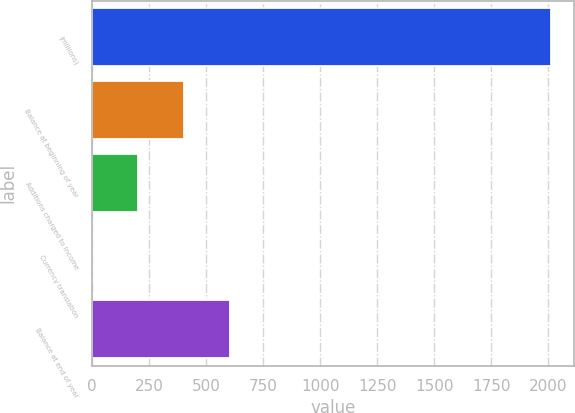Convert chart. <chart><loc_0><loc_0><loc_500><loc_500><bar_chart><fcel>(millions)<fcel>Balance at beginning of year<fcel>Additions charged to income<fcel>Currency translation<fcel>Balance at end of year<nl><fcel>2012<fcel>403.2<fcel>202.1<fcel>1<fcel>604.3<nl></chart> 